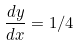Convert formula to latex. <formula><loc_0><loc_0><loc_500><loc_500>\frac { d y } { d x } = 1 / 4</formula> 